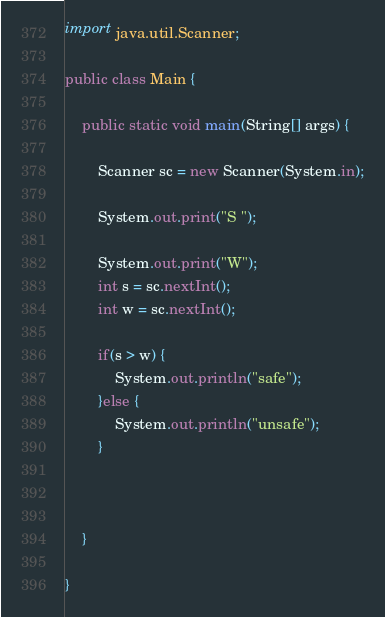Convert code to text. <code><loc_0><loc_0><loc_500><loc_500><_Java_>import java.util.Scanner;

public class Main {

	public static void main(String[] args) {
		
		Scanner sc = new Scanner(System.in);
		
		System.out.print("S ");

		System.out.print("W");
		int s = sc.nextInt();
		int w = sc.nextInt();
		
		if(s > w) {
			System.out.println("safe");
		}else {
			System.out.println("unsafe");
		}
		
		

	}

}
</code> 